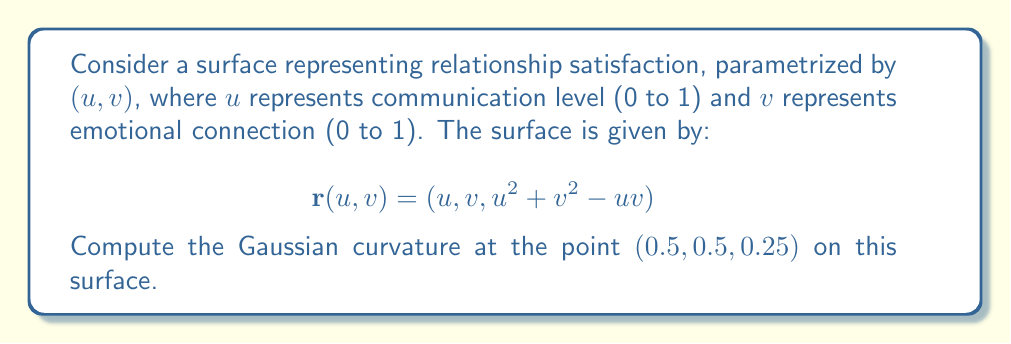Could you help me with this problem? To compute the Gaussian curvature, we need to follow these steps:

1) First, we need to calculate the partial derivatives:
   $$\mathbf{r}_u = (1, 0, 2u - v)$$
   $$\mathbf{r}_v = (0, 1, 2v - u)$$

2) Next, we calculate the second partial derivatives:
   $$\mathbf{r}_{uu} = (0, 0, 2)$$
   $$\mathbf{r}_{uv} = \mathbf{r}_{vu} = (0, 0, -1)$$
   $$\mathbf{r}_{vv} = (0, 0, 2)$$

3) Now we calculate the coefficients of the first fundamental form:
   $$E = \mathbf{r}_u \cdot \mathbf{r}_u = 1 + (2u-v)^2$$
   $$F = \mathbf{r}_u \cdot \mathbf{r}_v = (2u-v)(2v-u)$$
   $$G = \mathbf{r}_v \cdot \mathbf{r}_v = 1 + (2v-u)^2$$

4) We also need the normal vector:
   $$\mathbf{N} = \frac{\mathbf{r}_u \times \mathbf{r}_v}{|\mathbf{r}_u \times \mathbf{r}_v|} = \frac{(v-2u, u-2v, 1)}{\sqrt{(v-2u)^2 + (u-2v)^2 + 1}}$$

5) Now we calculate the coefficients of the second fundamental form:
   $$L = \mathbf{r}_{uu} \cdot \mathbf{N} = \frac{2}{\sqrt{(v-2u)^2 + (u-2v)^2 + 1}}$$
   $$M = \mathbf{r}_{uv} \cdot \mathbf{N} = \frac{-1}{\sqrt{(v-2u)^2 + (u-2v)^2 + 1}}$$
   $$N = \mathbf{r}_{vv} \cdot \mathbf{N} = \frac{2}{\sqrt{(v-2u)^2 + (u-2v)^2 + 1}}$$

6) The Gaussian curvature is given by:
   $$K = \frac{LN - M^2}{EG - F^2}$$

7) At the point (0.5, 0.5, 0.25), we have u = v = 0.5. Substituting these values:
   $$E = G = 1.25, F = 0.25$$
   $$L = N = \frac{2}{\sqrt{1.5}}, M = -\frac{1}{\sqrt{1.5}}$$

8) Finally, we can calculate K:
   $$K = \frac{(\frac{2}{\sqrt{1.5}})^2 - (-\frac{1}{\sqrt{1.5}})^2}{1.25^2 - 0.25^2} = \frac{3/1.5}{1.5} = \frac{2}{3}$$

Therefore, the Gaussian curvature at (0.5, 0.5, 0.25) is 2/3.
Answer: $\frac{2}{3}$ 